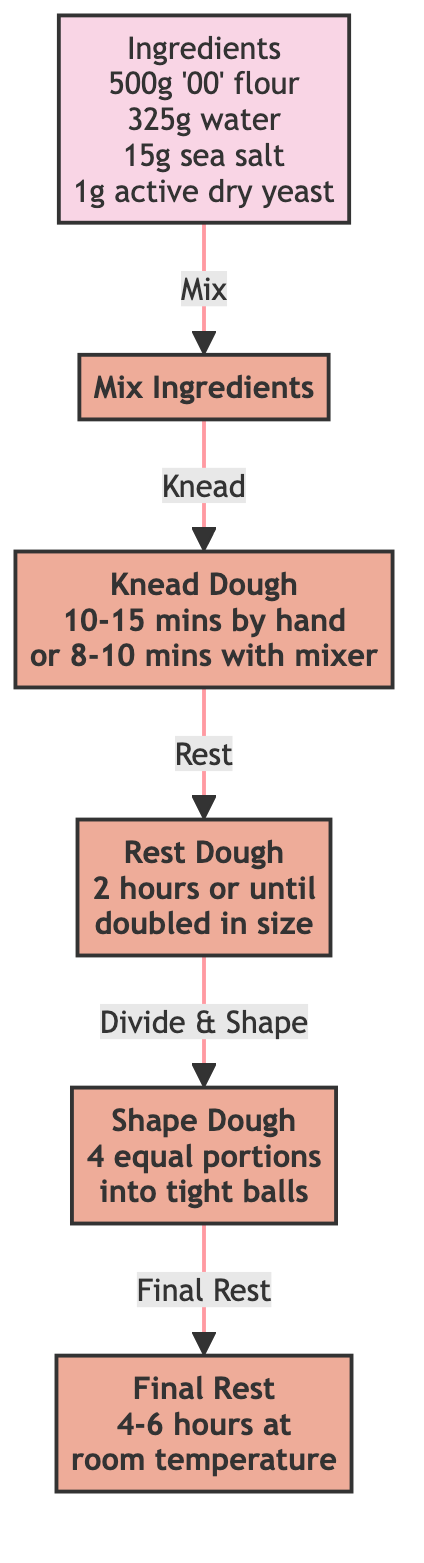What are the ingredients needed for the dough? The diagram lists four ingredients: 500 grams of '00' flour, 325 grams of water, 15 grams of sea salt, and 1 gram of active dry yeast.
Answer: 500 grams of '00' flour, 325 grams of water, 15 grams of sea salt, 1 gram of active dry yeast How long should the dough be kneaded? The diagram states that the dough should be kneaded for 10-15 minutes by hand or 8-10 minutes using a mixer with a dough hook.
Answer: 10-15 minutes by hand or 8-10 minutes with a mixer What is the duration for the first resting of the dough? According to the diagram, the dough should rest for 2 hours at room temperature or until it has doubled in size.
Answer: 2 hours or until doubled in size What do you do after mixing the ingredients? The diagram shows that after mixing the ingredients, the next step is to knead the dough.
Answer: Knead the dough How many portions is the dough divided into after kneading? The flow chart specifies that the dough is divided into 4 equal portions after kneading.
Answer: 4 What is the final resting time for the shaped dough? The diagram indicates that the final resting time for the shaped dough is another 4-6 hours at room temperature.
Answer: 4-6 hours at room temperature Which step follows after resting the dough? The flow chart indicates that after resting the dough, the next step is to shape the dough into portions.
Answer: Shape dough What is the relationship between the "Mix Ingredients" step and the "Knead Dough" step? The diagram shows a directional flow indicating that mixing the ingredients directly leads to the kneading of the dough, suggesting that kneading occurs immediately after mixing.
Answer: Mix leads to Knead What does the diagram suggest for covering the dough balls? The flow chart specifies that dough balls should be covered with a damp cloth during the final resting period.
Answer: Cover with a damp cloth 